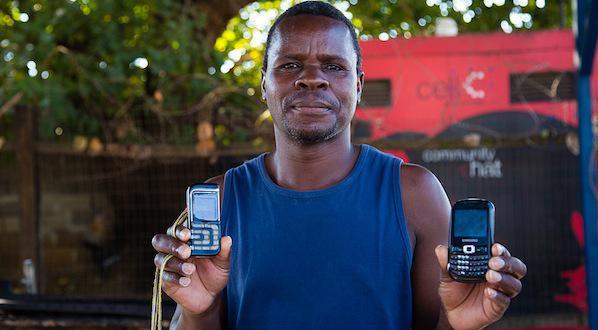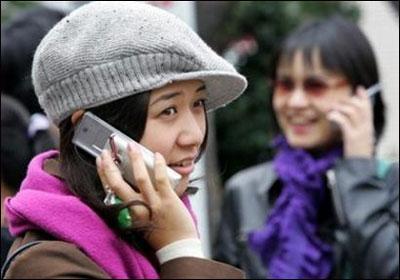The first image is the image on the left, the second image is the image on the right. Evaluate the accuracy of this statement regarding the images: "Three or more humans are visible.". Is it true? Answer yes or no. Yes. The first image is the image on the left, the second image is the image on the right. Given the left and right images, does the statement "A person is holding two phones in the right image." hold true? Answer yes or no. No. 